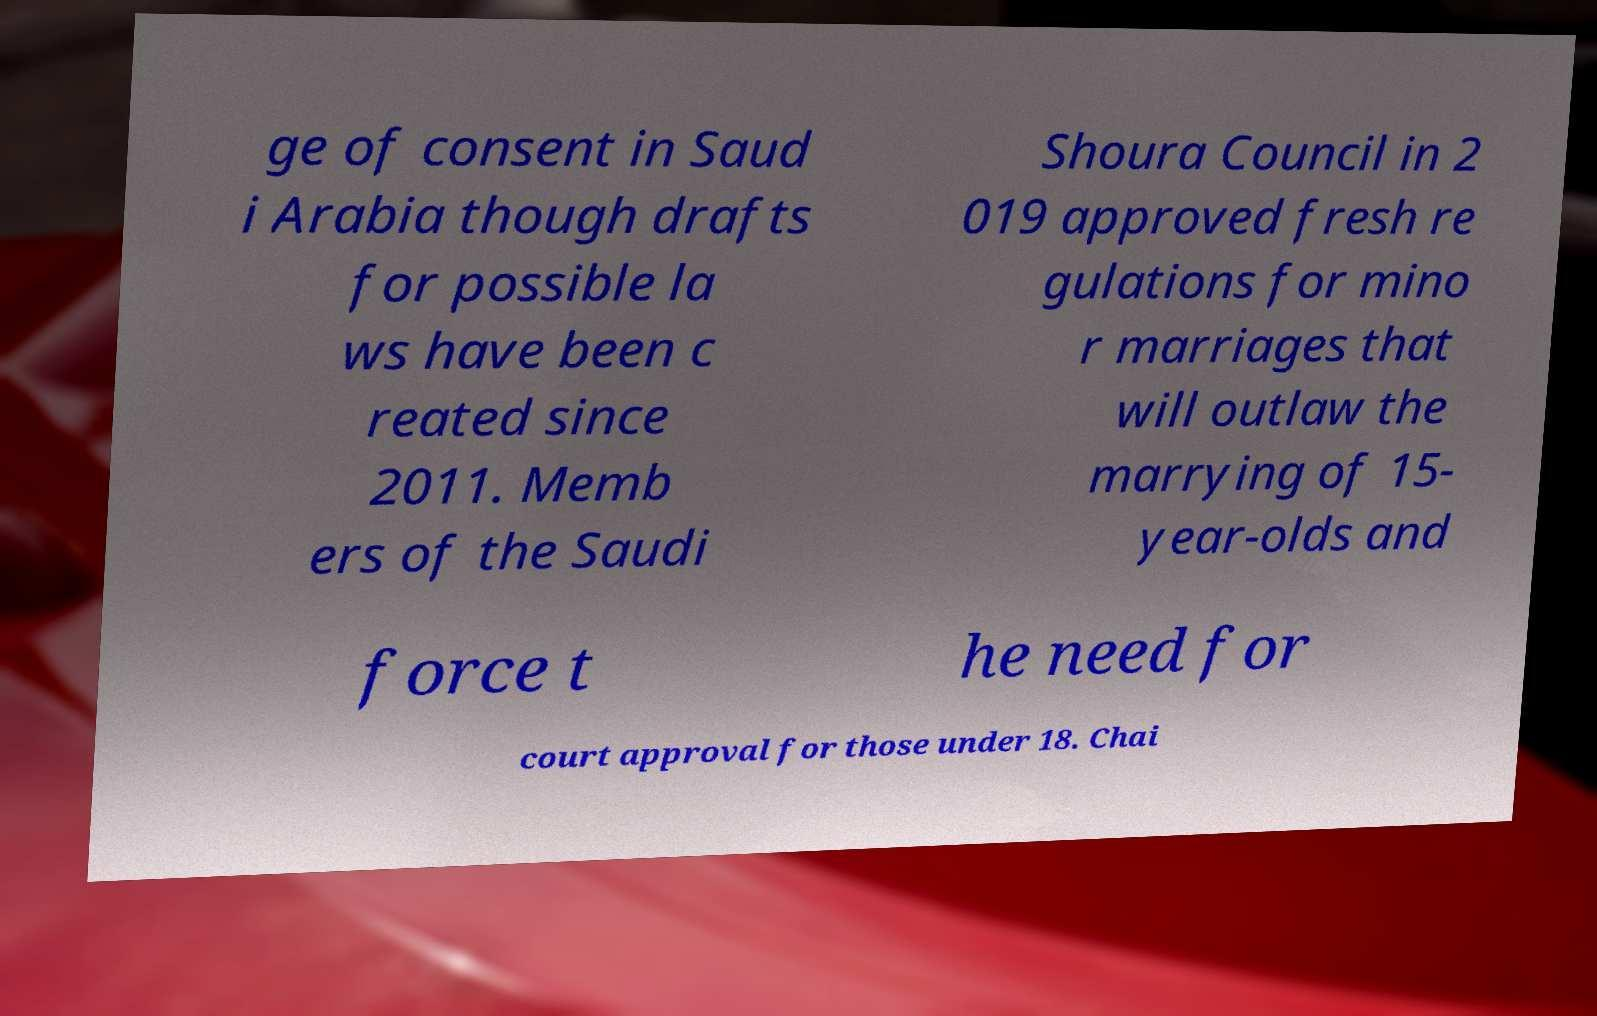There's text embedded in this image that I need extracted. Can you transcribe it verbatim? ge of consent in Saud i Arabia though drafts for possible la ws have been c reated since 2011. Memb ers of the Saudi Shoura Council in 2 019 approved fresh re gulations for mino r marriages that will outlaw the marrying of 15- year-olds and force t he need for court approval for those under 18. Chai 